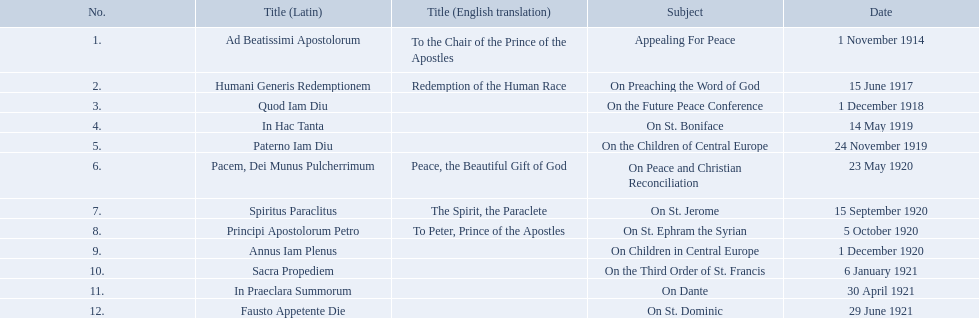What is the dates of the list of encyclicals of pope benedict xv? 1 November 1914, 15 June 1917, 1 December 1918, 14 May 1919, 24 November 1919, 23 May 1920, 15 September 1920, 5 October 1920, 1 December 1920, 6 January 1921, 30 April 1921, 29 June 1921. Of these dates, which subject was on 23 may 1920? On Peace and Christian Reconciliation. What are the entirety of the subjects? Appealing For Peace, On Preaching the Word of God, On the Future Peace Conference, On St. Boniface, On the Children of Central Europe, On Peace and Christian Reconciliation, On St. Jerome, On St. Ephram the Syrian, On Children in Central Europe, On the Third Order of St. Francis, On Dante, On St. Dominic. What are their respective dates? 1 November 1914, 15 June 1917, 1 December 1918, 14 May 1919, 24 November 1919, 23 May 1920, 15 September 1920, 5 October 1920, 1 December 1920, 6 January 1921, 30 April 1921, 29 June 1921. Which subject's date corresponds to 23 may 1920? On Peace and Christian Reconciliation. 